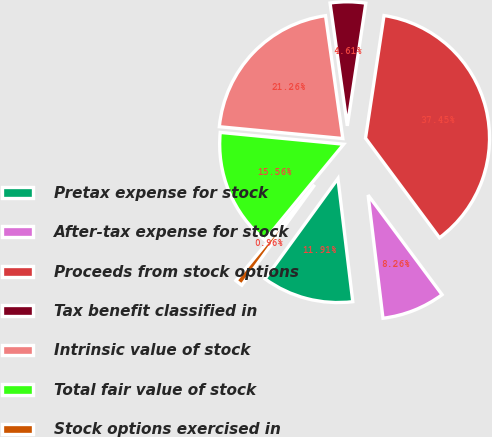Convert chart. <chart><loc_0><loc_0><loc_500><loc_500><pie_chart><fcel>Pretax expense for stock<fcel>After-tax expense for stock<fcel>Proceeds from stock options<fcel>Tax benefit classified in<fcel>Intrinsic value of stock<fcel>Total fair value of stock<fcel>Stock options exercised in<nl><fcel>11.91%<fcel>8.26%<fcel>37.45%<fcel>4.61%<fcel>21.26%<fcel>15.56%<fcel>0.96%<nl></chart> 